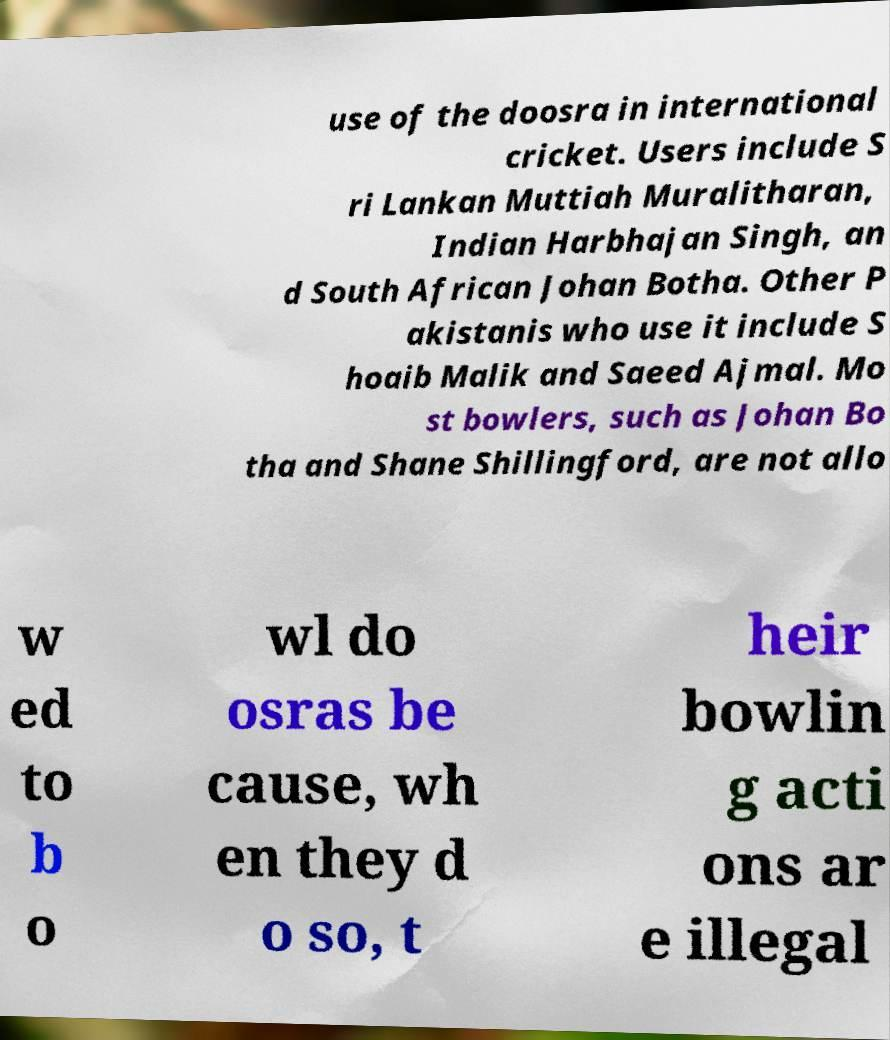Can you accurately transcribe the text from the provided image for me? use of the doosra in international cricket. Users include S ri Lankan Muttiah Muralitharan, Indian Harbhajan Singh, an d South African Johan Botha. Other P akistanis who use it include S hoaib Malik and Saeed Ajmal. Mo st bowlers, such as Johan Bo tha and Shane Shillingford, are not allo w ed to b o wl do osras be cause, wh en they d o so, t heir bowlin g acti ons ar e illegal 